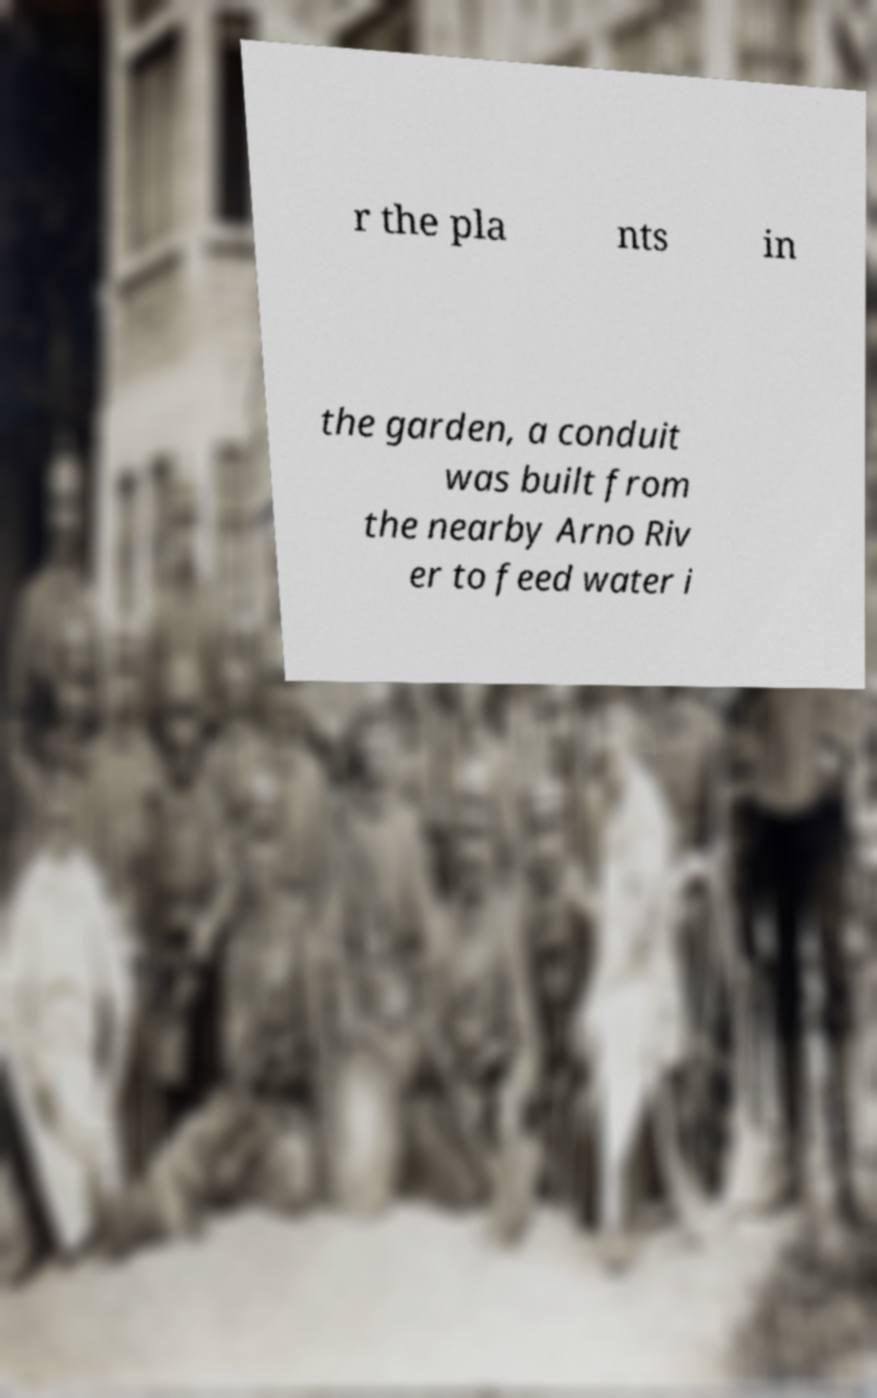There's text embedded in this image that I need extracted. Can you transcribe it verbatim? r the pla nts in the garden, a conduit was built from the nearby Arno Riv er to feed water i 